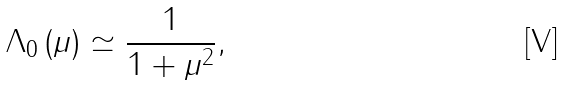<formula> <loc_0><loc_0><loc_500><loc_500>\Lambda _ { 0 } \left ( \mu \right ) \simeq \frac { 1 } { 1 + \mu ^ { 2 } } ,</formula> 